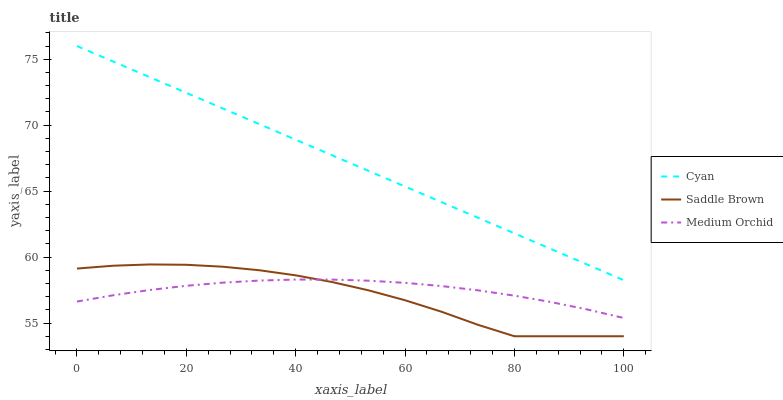Does Saddle Brown have the minimum area under the curve?
Answer yes or no. Yes. Does Cyan have the maximum area under the curve?
Answer yes or no. Yes. Does Medium Orchid have the minimum area under the curve?
Answer yes or no. No. Does Medium Orchid have the maximum area under the curve?
Answer yes or no. No. Is Cyan the smoothest?
Answer yes or no. Yes. Is Saddle Brown the roughest?
Answer yes or no. Yes. Is Medium Orchid the smoothest?
Answer yes or no. No. Is Medium Orchid the roughest?
Answer yes or no. No. Does Saddle Brown have the lowest value?
Answer yes or no. Yes. Does Medium Orchid have the lowest value?
Answer yes or no. No. Does Cyan have the highest value?
Answer yes or no. Yes. Does Saddle Brown have the highest value?
Answer yes or no. No. Is Medium Orchid less than Cyan?
Answer yes or no. Yes. Is Cyan greater than Medium Orchid?
Answer yes or no. Yes. Does Saddle Brown intersect Medium Orchid?
Answer yes or no. Yes. Is Saddle Brown less than Medium Orchid?
Answer yes or no. No. Is Saddle Brown greater than Medium Orchid?
Answer yes or no. No. Does Medium Orchid intersect Cyan?
Answer yes or no. No. 